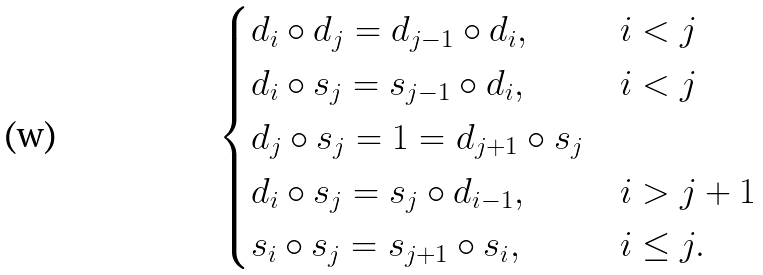Convert formula to latex. <formula><loc_0><loc_0><loc_500><loc_500>\begin{cases} d _ { i } \circ d _ { j } = d _ { j - 1 } \circ d _ { i } , & i < j \\ d _ { i } \circ s _ { j } = s _ { j - 1 } \circ d _ { i } , & i < j \\ d _ { j } \circ s _ { j } = 1 = d _ { j + 1 } \circ s _ { j } \\ d _ { i } \circ s _ { j } = s _ { j } \circ d _ { i - 1 } , & i > j + 1 \\ s _ { i } \circ s _ { j } = s _ { j + 1 } \circ s _ { i } , & i \leq j . \end{cases}</formula> 